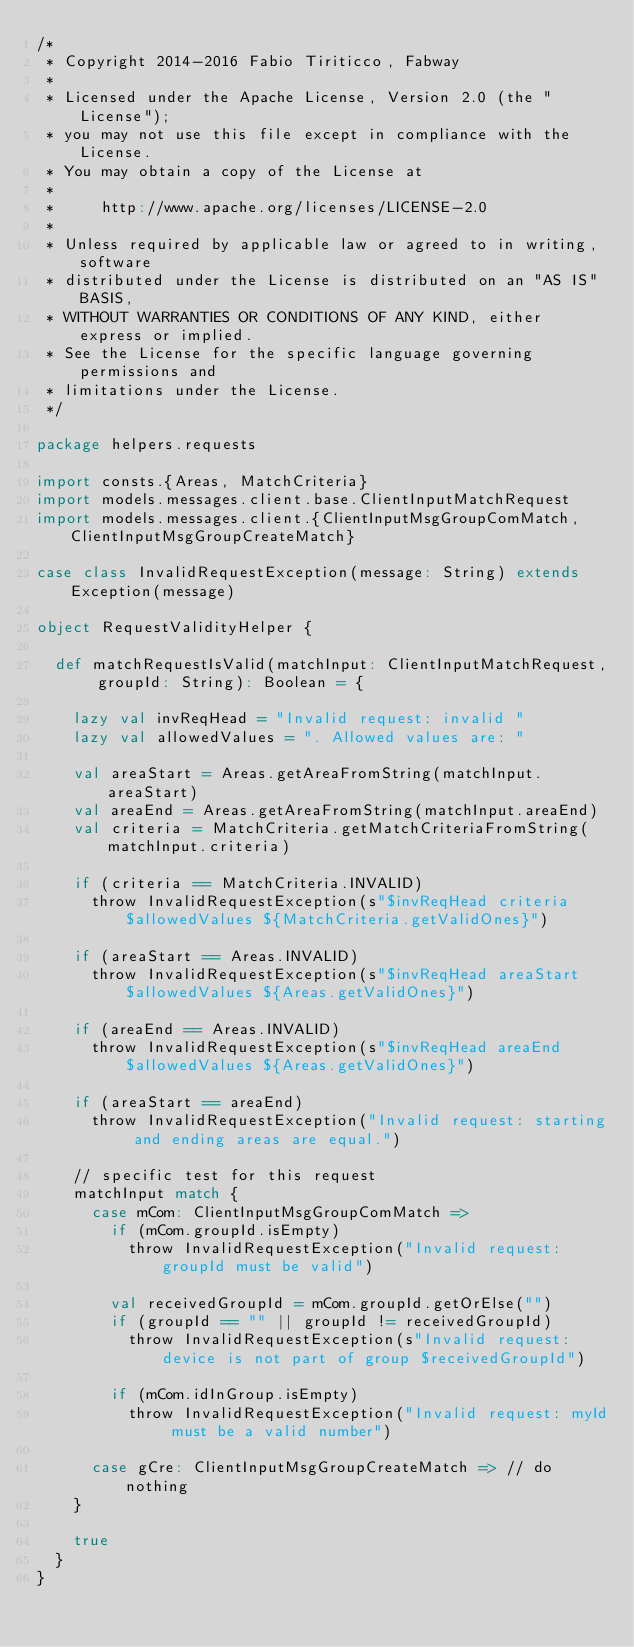Convert code to text. <code><loc_0><loc_0><loc_500><loc_500><_Scala_>/*
 * Copyright 2014-2016 Fabio Tiriticco, Fabway
 *
 * Licensed under the Apache License, Version 2.0 (the "License");
 * you may not use this file except in compliance with the License.
 * You may obtain a copy of the License at
 *
 *     http://www.apache.org/licenses/LICENSE-2.0
 *
 * Unless required by applicable law or agreed to in writing, software
 * distributed under the License is distributed on an "AS IS" BASIS,
 * WITHOUT WARRANTIES OR CONDITIONS OF ANY KIND, either express or implied.
 * See the License for the specific language governing permissions and
 * limitations under the License.
 */

package helpers.requests

import consts.{Areas, MatchCriteria}
import models.messages.client.base.ClientInputMatchRequest
import models.messages.client.{ClientInputMsgGroupComMatch, ClientInputMsgGroupCreateMatch}

case class InvalidRequestException(message: String) extends Exception(message)

object RequestValidityHelper {

  def matchRequestIsValid(matchInput: ClientInputMatchRequest, groupId: String): Boolean = {

    lazy val invReqHead = "Invalid request: invalid "
    lazy val allowedValues = ". Allowed values are: "

    val areaStart = Areas.getAreaFromString(matchInput.areaStart)
    val areaEnd = Areas.getAreaFromString(matchInput.areaEnd)
    val criteria = MatchCriteria.getMatchCriteriaFromString(matchInput.criteria)

    if (criteria == MatchCriteria.INVALID)
      throw InvalidRequestException(s"$invReqHead criteria $allowedValues ${MatchCriteria.getValidOnes}")

    if (areaStart == Areas.INVALID)
      throw InvalidRequestException(s"$invReqHead areaStart $allowedValues ${Areas.getValidOnes}")

    if (areaEnd == Areas.INVALID)
      throw InvalidRequestException(s"$invReqHead areaEnd $allowedValues ${Areas.getValidOnes}")

    if (areaStart == areaEnd)
      throw InvalidRequestException("Invalid request: starting and ending areas are equal.")

    // specific test for this request
    matchInput match {
      case mCom: ClientInputMsgGroupComMatch =>
        if (mCom.groupId.isEmpty)
          throw InvalidRequestException("Invalid request: groupId must be valid")

        val receivedGroupId = mCom.groupId.getOrElse("")
        if (groupId == "" || groupId != receivedGroupId)
          throw InvalidRequestException(s"Invalid request: device is not part of group $receivedGroupId")

        if (mCom.idInGroup.isEmpty)
          throw InvalidRequestException("Invalid request: myId must be a valid number")

      case gCre: ClientInputMsgGroupCreateMatch => // do nothing
    }

    true
  }
}
</code> 